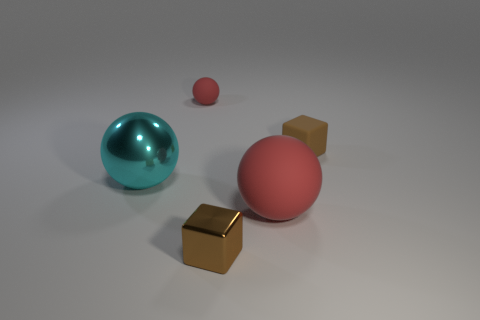Add 1 big red matte cylinders. How many objects exist? 6 Subtract all balls. How many objects are left? 2 Add 2 red things. How many red things are left? 4 Add 2 cyan objects. How many cyan objects exist? 3 Subtract 0 brown cylinders. How many objects are left? 5 Subtract all small red rubber balls. Subtract all small brown metallic cubes. How many objects are left? 3 